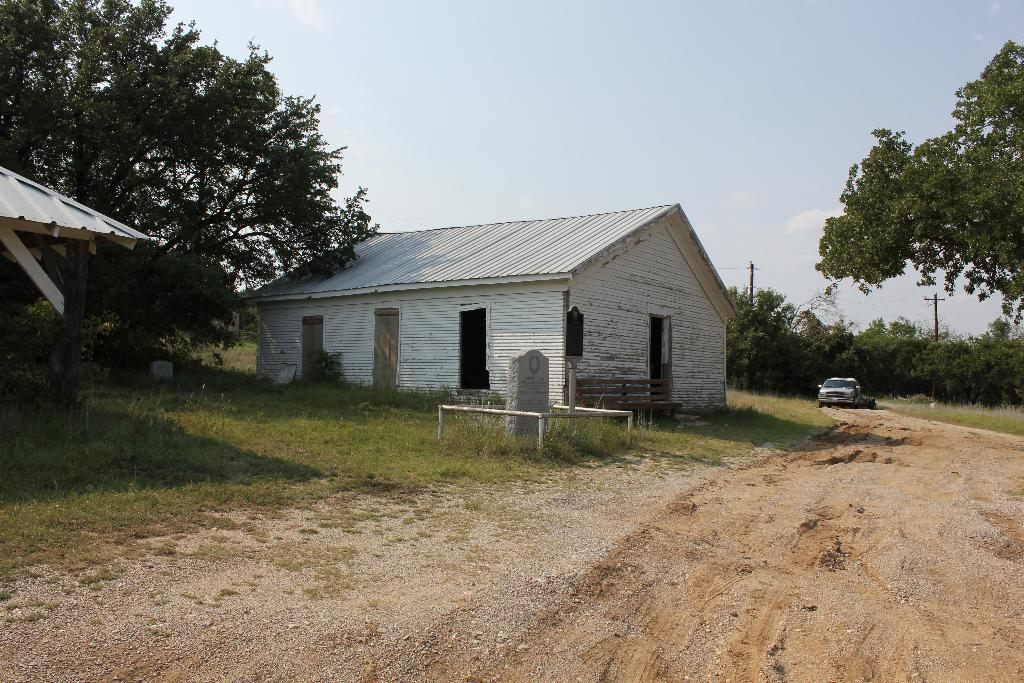What can be seen in the sky in the image? The sky is visible in the image, but no specific details about the sky are mentioned. What type of vegetation is present in the image? There are trees and grass visible in the image. What type of structure can be seen in the image? There is a shed and a building in the image. What type of ground surface is present in the image? Laid stone is present in the image. What type of infrastructure is visible in the image? Electric poles and electric cables are visible in the image. What type of transportation is present in the image? Motor vehicles are on the ground in the image. Can you tell me how many parents are visible in the image? There is no mention of parents in the image. What type of animal is visible with a tail in the image? There is no mention of animals or tails in the image. 